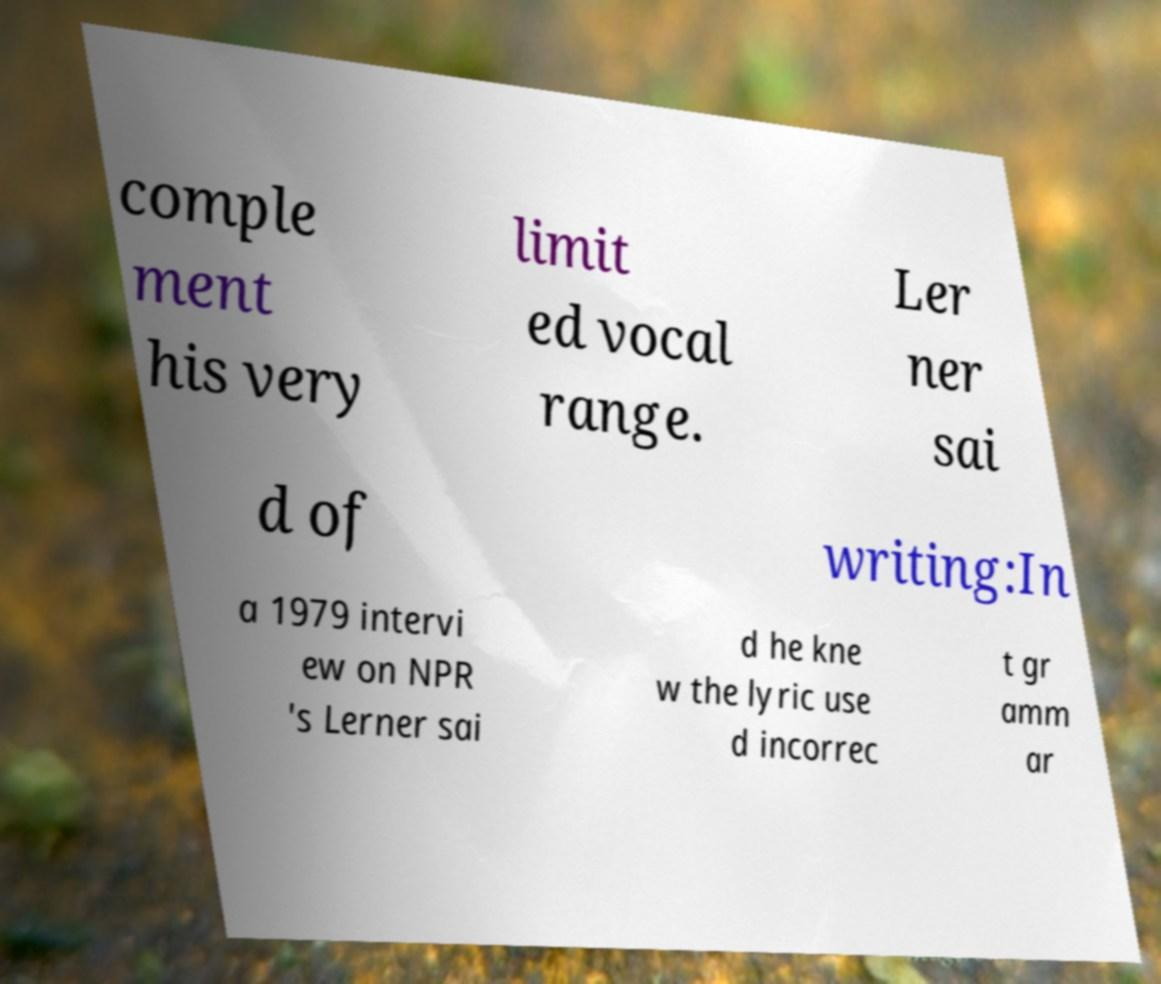What messages or text are displayed in this image? I need them in a readable, typed format. comple ment his very limit ed vocal range. Ler ner sai d of writing:In a 1979 intervi ew on NPR 's Lerner sai d he kne w the lyric use d incorrec t gr amm ar 